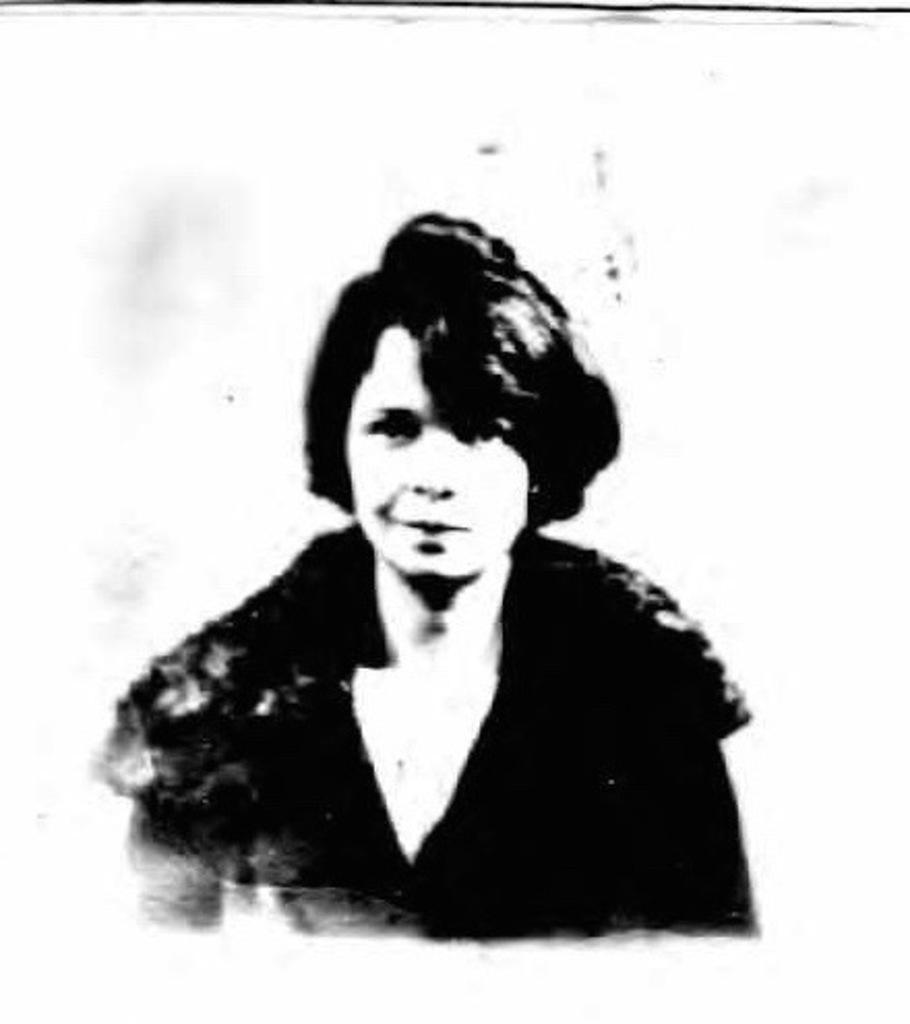Describe this image in one or two sentences. In this image we can see a photo. There is a person in the image. There is a white color background in the image. 